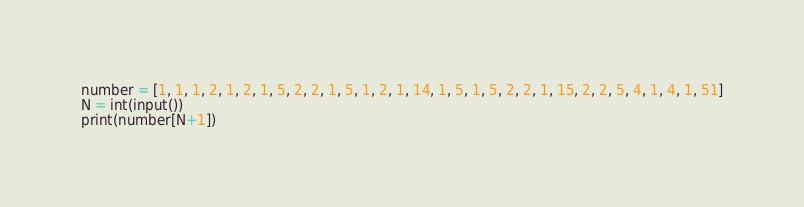<code> <loc_0><loc_0><loc_500><loc_500><_Python_>number = [1, 1, 1, 2, 1, 2, 1, 5, 2, 2, 1, 5, 1, 2, 1, 14, 1, 5, 1, 5, 2, 2, 1, 15, 2, 2, 5, 4, 1, 4, 1, 51]
N = int(input())
print(number[N+1])</code> 